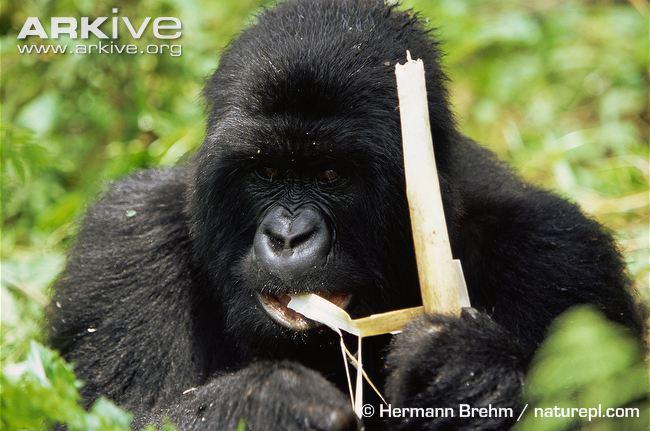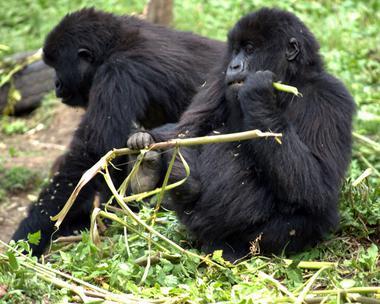The first image is the image on the left, the second image is the image on the right. Given the left and right images, does the statement "The right image includes twice the number of gorillas as the left image." hold true? Answer yes or no. Yes. 